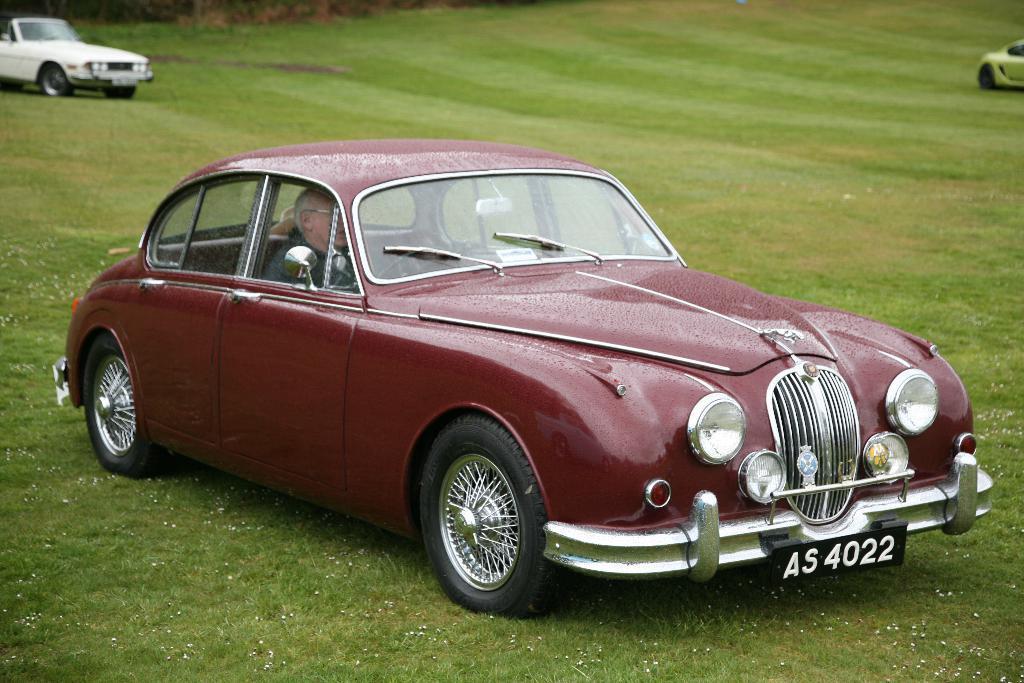Could you give a brief overview of what you see in this image? In this picture we can see a person in a car. There are few vehicles on the grass. 